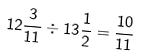<formula> <loc_0><loc_0><loc_500><loc_500>1 2 \frac { 3 } { 1 1 } \div 1 3 \frac { 1 } { 2 } = \frac { 1 0 } { 1 1 }</formula> 